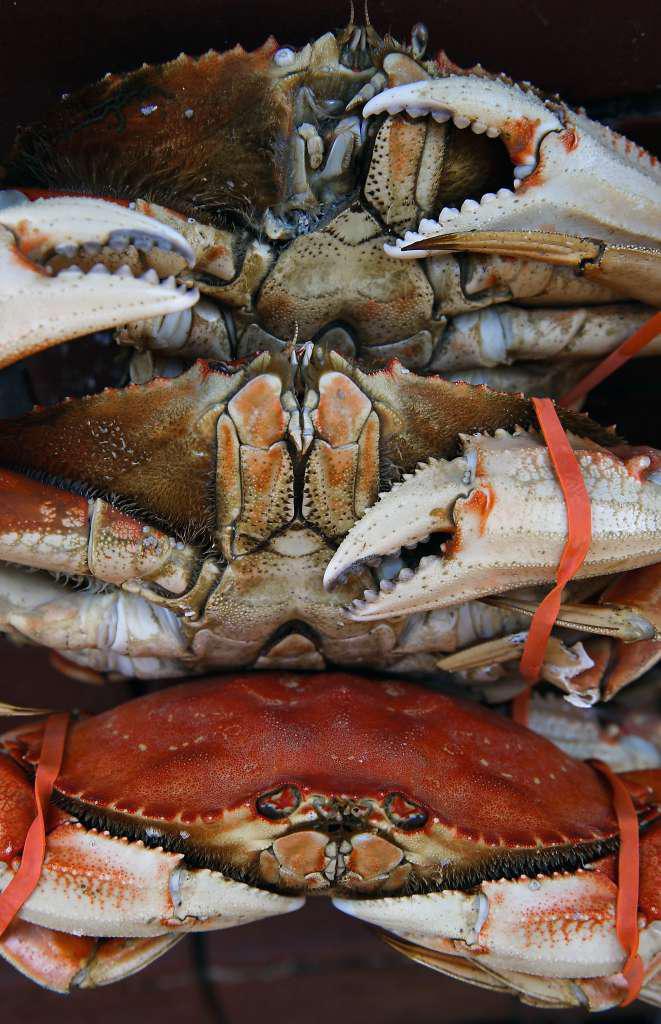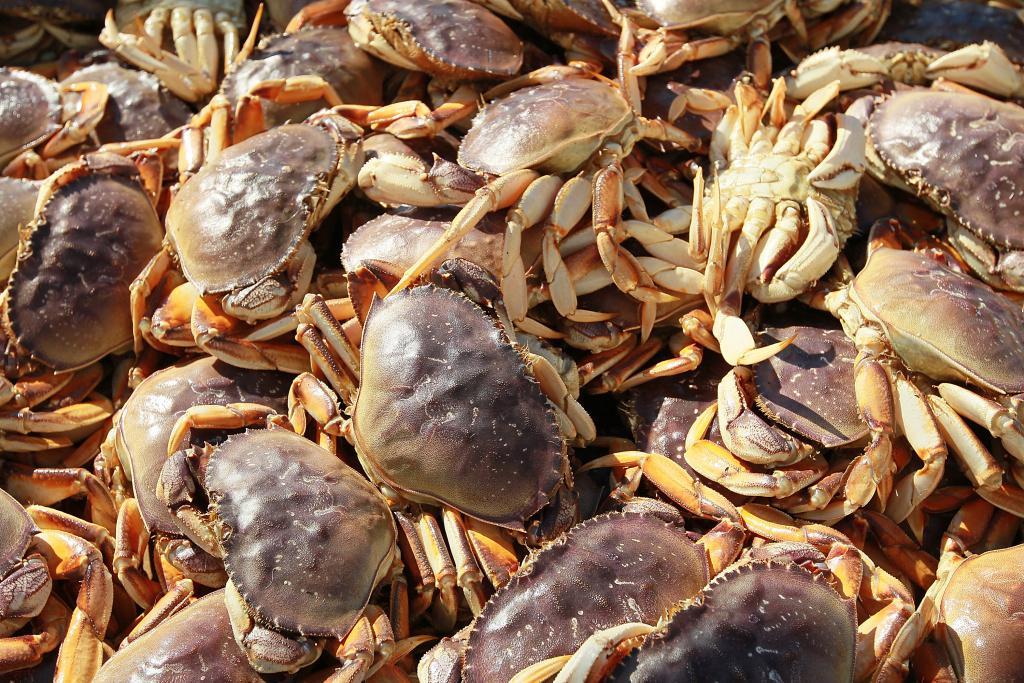The first image is the image on the left, the second image is the image on the right. Examine the images to the left and right. Is the description "There are three crabs stacked on top of each other." accurate? Answer yes or no. Yes. The first image is the image on the left, the second image is the image on the right. Examine the images to the left and right. Is the description "there are 3 crabs stacked on top of each other, all three are upside down" accurate? Answer yes or no. No. 